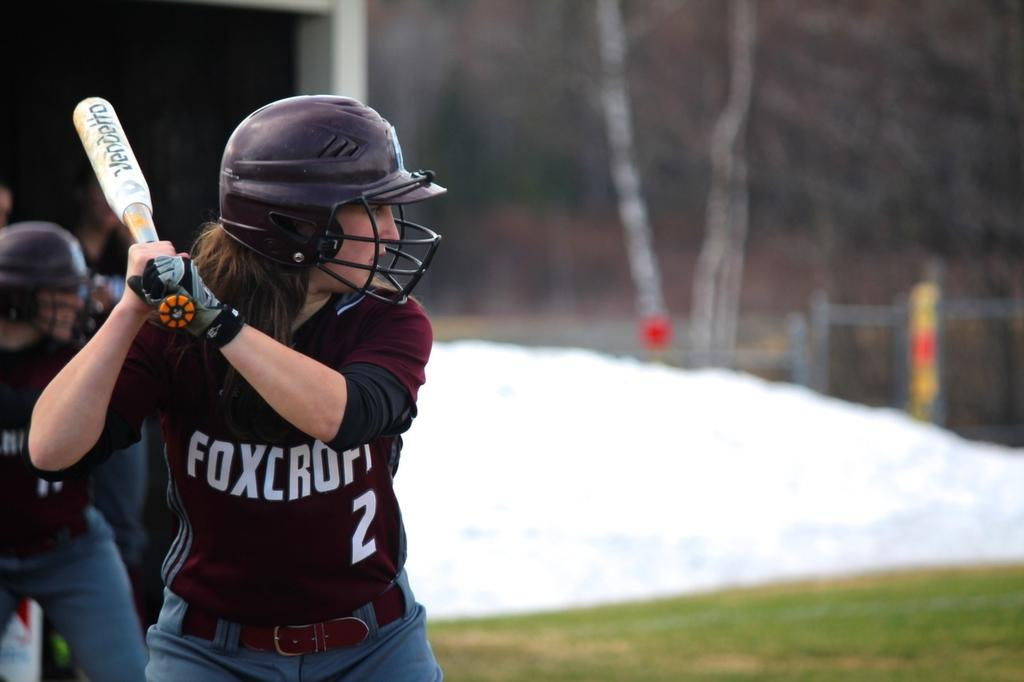How many people are on the left side of the image? There are two persons on the left side of the image. What are the people wearing? Both persons are wearing brown color T-shirts. What is one of the persons holding? One of the persons is holding a bat. What type of surface is on the right side of the image? The ground on the right side of the image has grass. What type of food is being prepared on the right side of the image? There is no food preparation visible in the image; it only shows two persons and a grassy surface on the right side. 